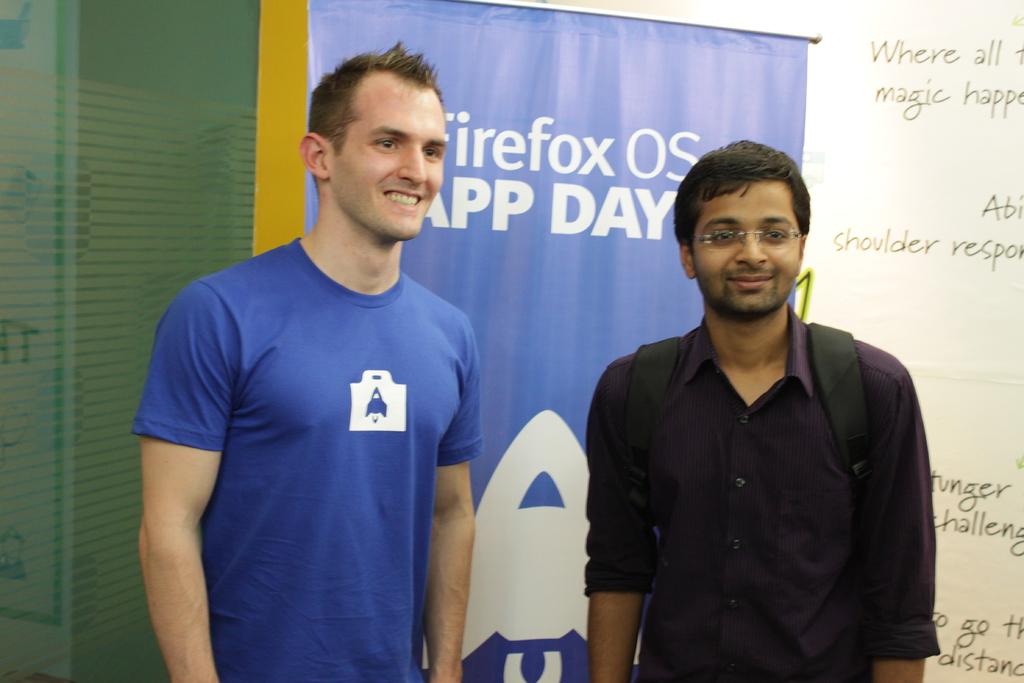What operating system are they advocating?
Keep it short and to the point. Firefox. What kind of day does the sign say it is?
Provide a short and direct response. App. 